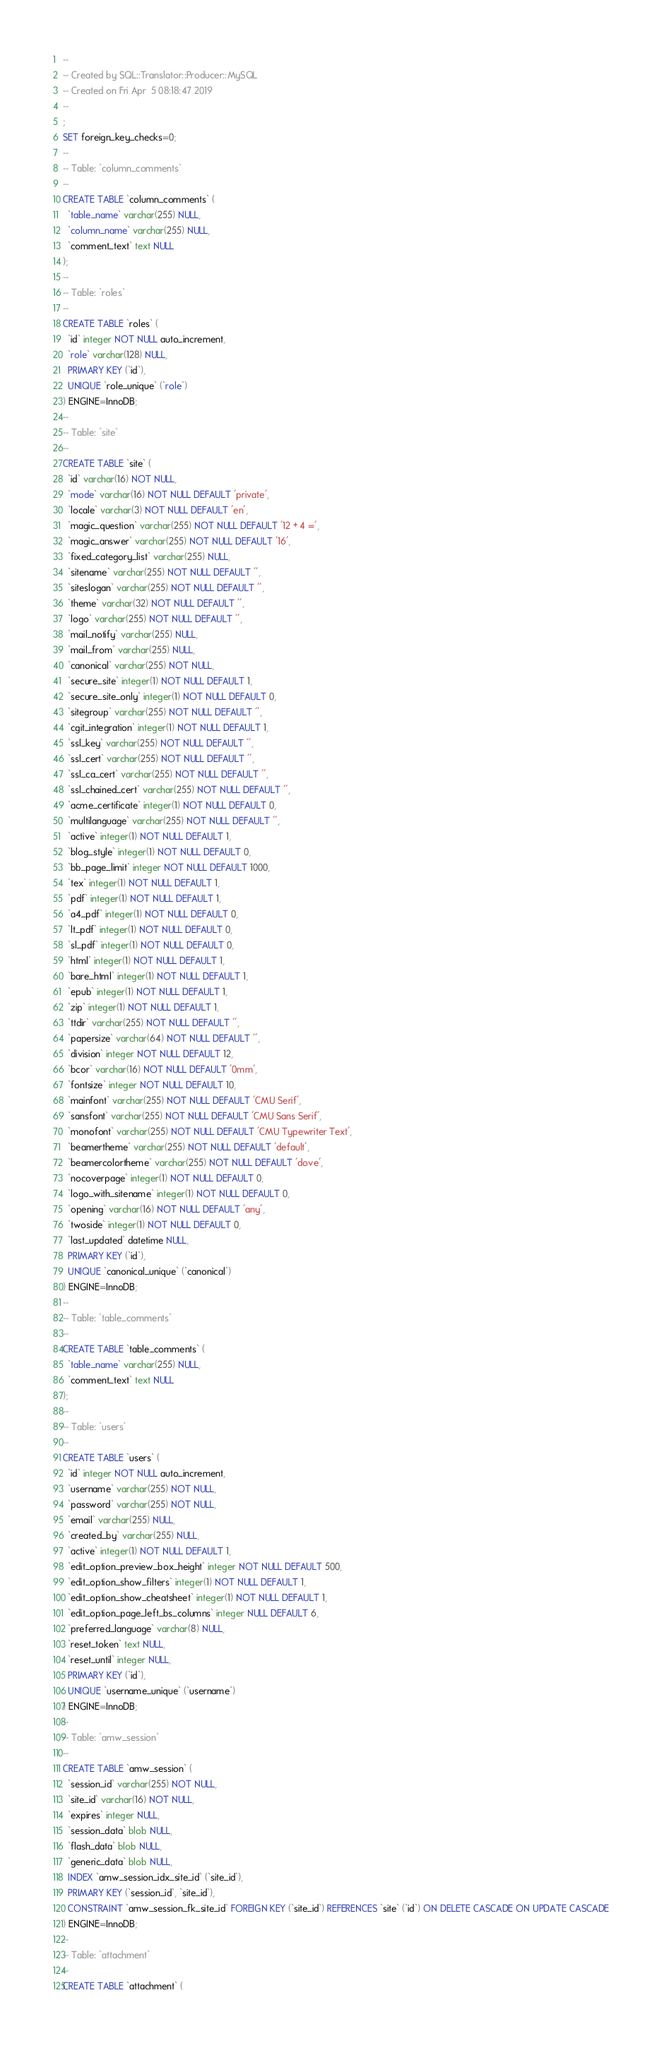<code> <loc_0><loc_0><loc_500><loc_500><_SQL_>-- 
-- Created by SQL::Translator::Producer::MySQL
-- Created on Fri Apr  5 08:18:47 2019
-- 
;
SET foreign_key_checks=0;
--
-- Table: `column_comments`
--
CREATE TABLE `column_comments` (
  `table_name` varchar(255) NULL,
  `column_name` varchar(255) NULL,
  `comment_text` text NULL
);
--
-- Table: `roles`
--
CREATE TABLE `roles` (
  `id` integer NOT NULL auto_increment,
  `role` varchar(128) NULL,
  PRIMARY KEY (`id`),
  UNIQUE `role_unique` (`role`)
) ENGINE=InnoDB;
--
-- Table: `site`
--
CREATE TABLE `site` (
  `id` varchar(16) NOT NULL,
  `mode` varchar(16) NOT NULL DEFAULT 'private',
  `locale` varchar(3) NOT NULL DEFAULT 'en',
  `magic_question` varchar(255) NOT NULL DEFAULT '12 + 4 =',
  `magic_answer` varchar(255) NOT NULL DEFAULT '16',
  `fixed_category_list` varchar(255) NULL,
  `sitename` varchar(255) NOT NULL DEFAULT '',
  `siteslogan` varchar(255) NOT NULL DEFAULT '',
  `theme` varchar(32) NOT NULL DEFAULT '',
  `logo` varchar(255) NOT NULL DEFAULT '',
  `mail_notify` varchar(255) NULL,
  `mail_from` varchar(255) NULL,
  `canonical` varchar(255) NOT NULL,
  `secure_site` integer(1) NOT NULL DEFAULT 1,
  `secure_site_only` integer(1) NOT NULL DEFAULT 0,
  `sitegroup` varchar(255) NOT NULL DEFAULT '',
  `cgit_integration` integer(1) NOT NULL DEFAULT 1,
  `ssl_key` varchar(255) NOT NULL DEFAULT '',
  `ssl_cert` varchar(255) NOT NULL DEFAULT '',
  `ssl_ca_cert` varchar(255) NOT NULL DEFAULT '',
  `ssl_chained_cert` varchar(255) NOT NULL DEFAULT '',
  `acme_certificate` integer(1) NOT NULL DEFAULT 0,
  `multilanguage` varchar(255) NOT NULL DEFAULT '',
  `active` integer(1) NOT NULL DEFAULT 1,
  `blog_style` integer(1) NOT NULL DEFAULT 0,
  `bb_page_limit` integer NOT NULL DEFAULT 1000,
  `tex` integer(1) NOT NULL DEFAULT 1,
  `pdf` integer(1) NOT NULL DEFAULT 1,
  `a4_pdf` integer(1) NOT NULL DEFAULT 0,
  `lt_pdf` integer(1) NOT NULL DEFAULT 0,
  `sl_pdf` integer(1) NOT NULL DEFAULT 0,
  `html` integer(1) NOT NULL DEFAULT 1,
  `bare_html` integer(1) NOT NULL DEFAULT 1,
  `epub` integer(1) NOT NULL DEFAULT 1,
  `zip` integer(1) NOT NULL DEFAULT 1,
  `ttdir` varchar(255) NOT NULL DEFAULT '',
  `papersize` varchar(64) NOT NULL DEFAULT '',
  `division` integer NOT NULL DEFAULT 12,
  `bcor` varchar(16) NOT NULL DEFAULT '0mm',
  `fontsize` integer NOT NULL DEFAULT 10,
  `mainfont` varchar(255) NOT NULL DEFAULT 'CMU Serif',
  `sansfont` varchar(255) NOT NULL DEFAULT 'CMU Sans Serif',
  `monofont` varchar(255) NOT NULL DEFAULT 'CMU Typewriter Text',
  `beamertheme` varchar(255) NOT NULL DEFAULT 'default',
  `beamercolortheme` varchar(255) NOT NULL DEFAULT 'dove',
  `nocoverpage` integer(1) NOT NULL DEFAULT 0,
  `logo_with_sitename` integer(1) NOT NULL DEFAULT 0,
  `opening` varchar(16) NOT NULL DEFAULT 'any',
  `twoside` integer(1) NOT NULL DEFAULT 0,
  `last_updated` datetime NULL,
  PRIMARY KEY (`id`),
  UNIQUE `canonical_unique` (`canonical`)
) ENGINE=InnoDB;
--
-- Table: `table_comments`
--
CREATE TABLE `table_comments` (
  `table_name` varchar(255) NULL,
  `comment_text` text NULL
);
--
-- Table: `users`
--
CREATE TABLE `users` (
  `id` integer NOT NULL auto_increment,
  `username` varchar(255) NOT NULL,
  `password` varchar(255) NOT NULL,
  `email` varchar(255) NULL,
  `created_by` varchar(255) NULL,
  `active` integer(1) NOT NULL DEFAULT 1,
  `edit_option_preview_box_height` integer NOT NULL DEFAULT 500,
  `edit_option_show_filters` integer(1) NOT NULL DEFAULT 1,
  `edit_option_show_cheatsheet` integer(1) NOT NULL DEFAULT 1,
  `edit_option_page_left_bs_columns` integer NULL DEFAULT 6,
  `preferred_language` varchar(8) NULL,
  `reset_token` text NULL,
  `reset_until` integer NULL,
  PRIMARY KEY (`id`),
  UNIQUE `username_unique` (`username`)
) ENGINE=InnoDB;
--
-- Table: `amw_session`
--
CREATE TABLE `amw_session` (
  `session_id` varchar(255) NOT NULL,
  `site_id` varchar(16) NOT NULL,
  `expires` integer NULL,
  `session_data` blob NULL,
  `flash_data` blob NULL,
  `generic_data` blob NULL,
  INDEX `amw_session_idx_site_id` (`site_id`),
  PRIMARY KEY (`session_id`, `site_id`),
  CONSTRAINT `amw_session_fk_site_id` FOREIGN KEY (`site_id`) REFERENCES `site` (`id`) ON DELETE CASCADE ON UPDATE CASCADE
) ENGINE=InnoDB;
--
-- Table: `attachment`
--
CREATE TABLE `attachment` (</code> 